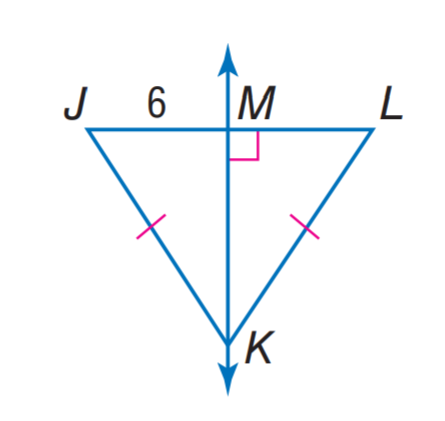Question: Find J L.
Choices:
A. 3
B. 6
C. 12
D. 24
Answer with the letter. Answer: C 